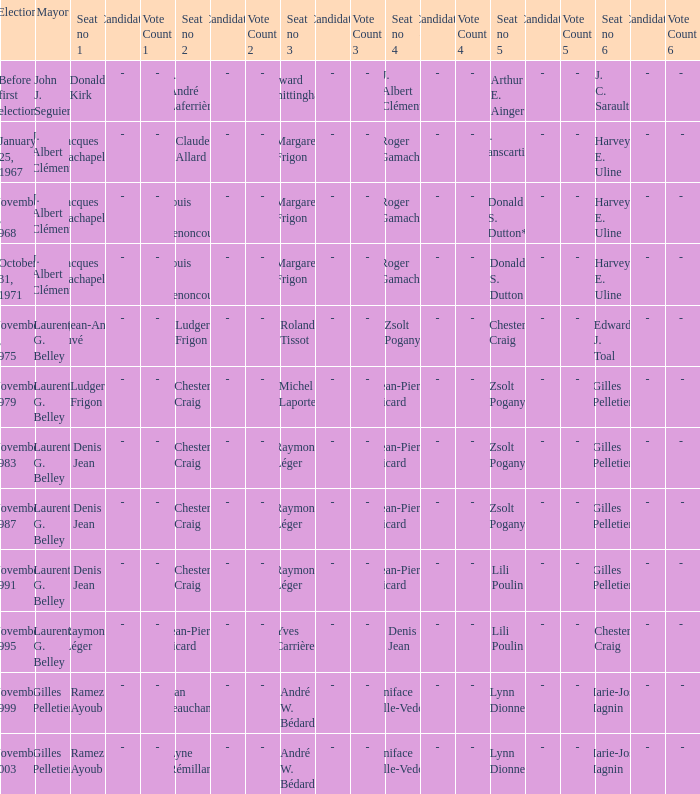Which election had seat no 1 filled by jacques lachapelle but seat no 5 was filled by g. sanscartier January 25, 1967. 